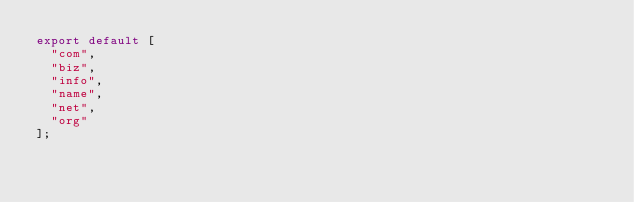Convert code to text. <code><loc_0><loc_0><loc_500><loc_500><_JavaScript_>export default [
  "com",
  "biz",
  "info",
  "name",
  "net",
  "org"
];
</code> 